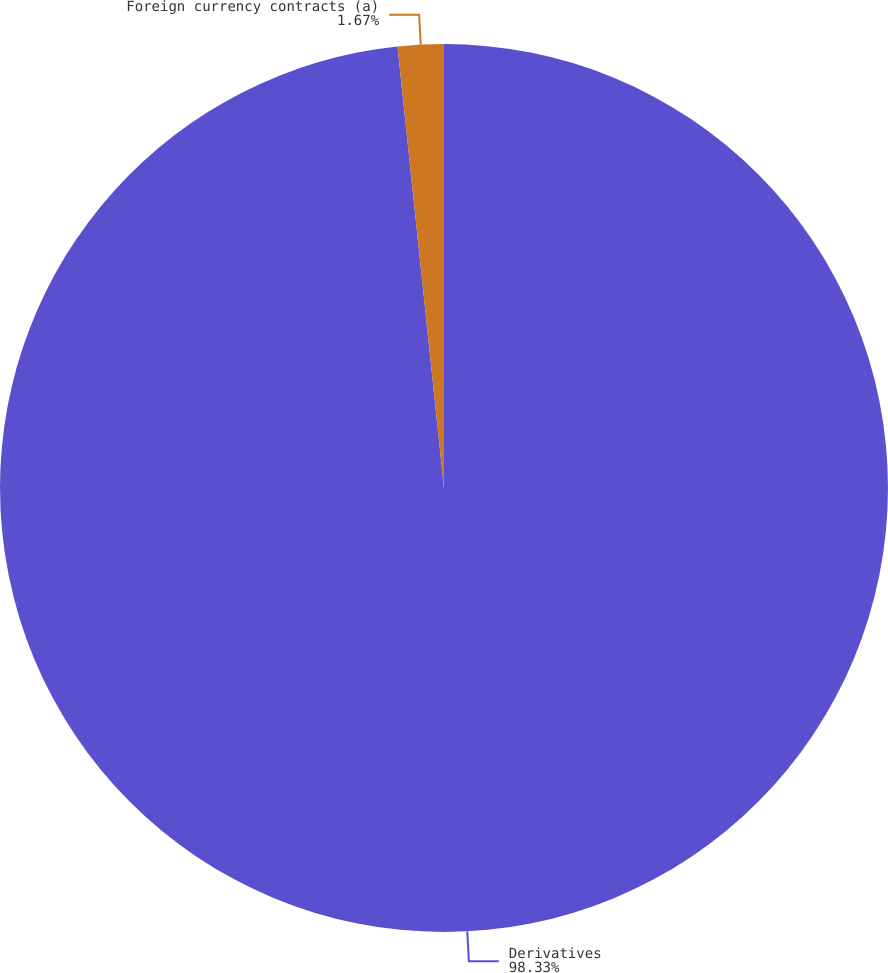Convert chart. <chart><loc_0><loc_0><loc_500><loc_500><pie_chart><fcel>Derivatives<fcel>Foreign currency contracts (a)<nl><fcel>98.33%<fcel>1.67%<nl></chart> 